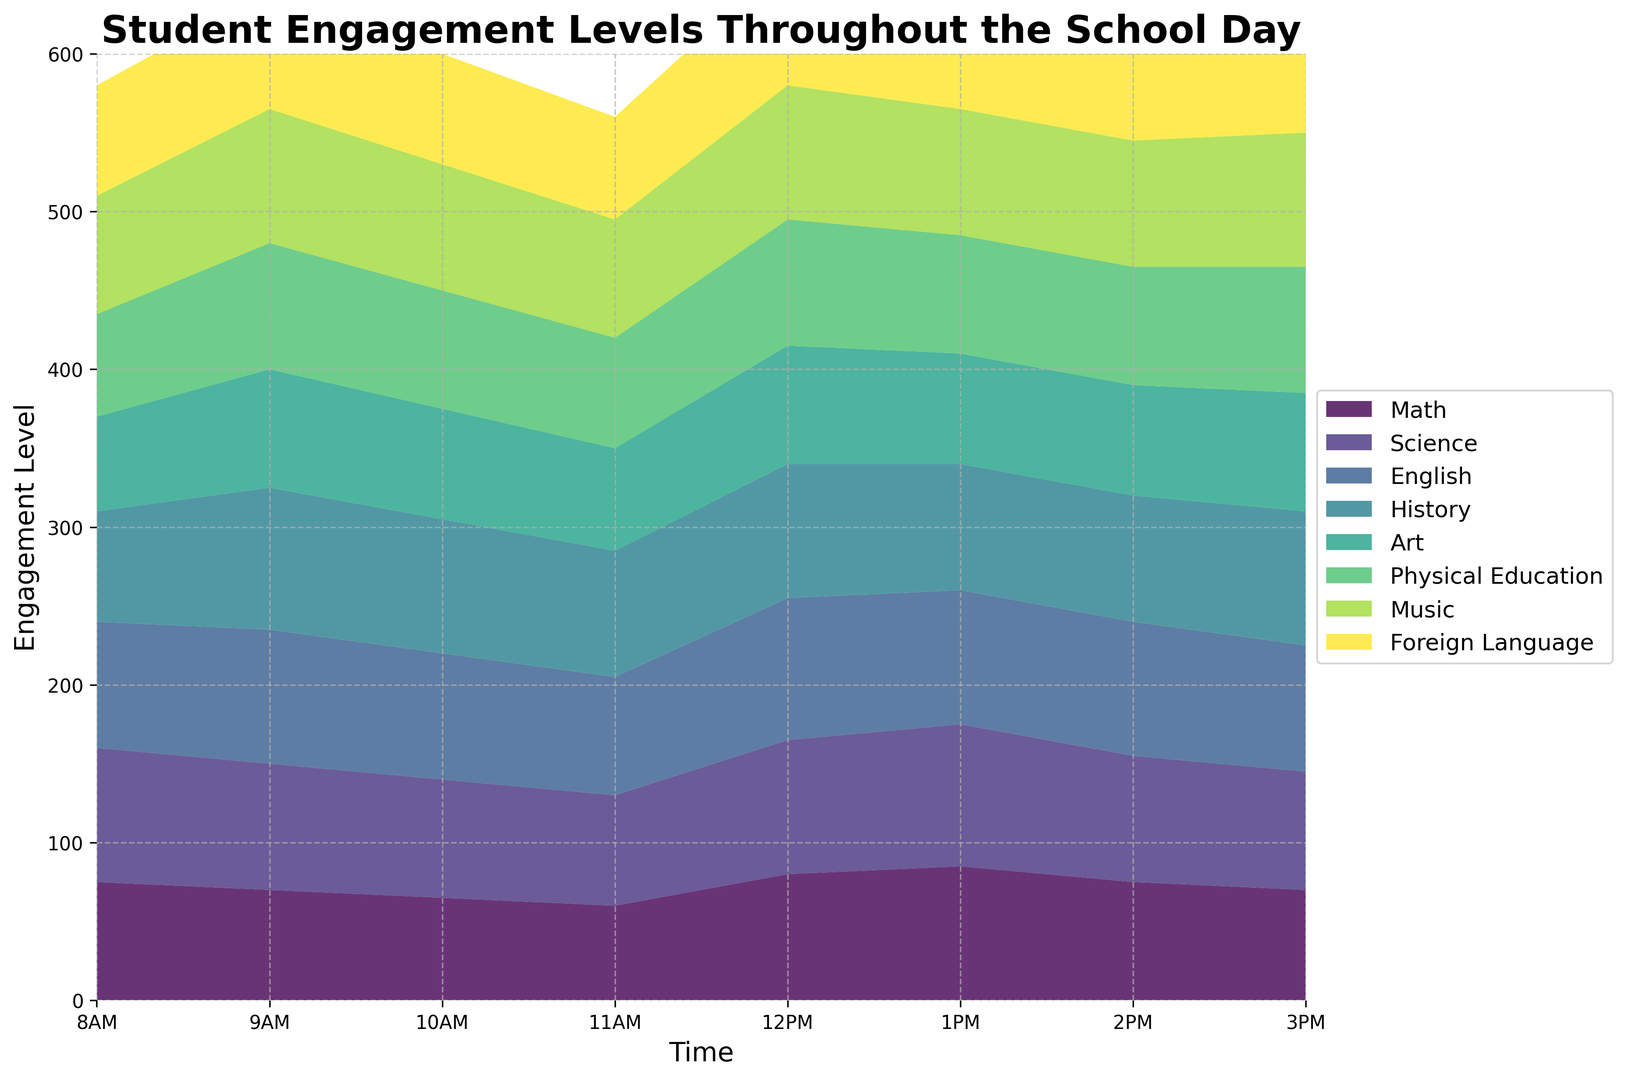What time of the day does Physical Education have the highest engagement level? From the graph, we can see the height of the Physical Education area (represented by its distinct color) is highest at 9AM.
Answer: 9AM Which subject shows a peak in student engagement at 11AM? Observing the heights of all areas at 11AM, the subject with the tallest area is Science.
Answer: Science Compare the engagement levels of Math and English at 10AM. Which one is higher? At 10AM, the height of the Math area is lower than the height of the English area.
Answer: English Summarize the student engagement level trend in Art from 8AM to 3PM. The engagement in Art starts high at 8AM, peaks at 10AM, stays relatively constant until 1PM, and then gradually decreases till 3PM.
Answer: High to moderate decrease What is the combined engagement level of Math and Science at 9AM? The engagement levels at 9AM are 85 (Math) and 80 (Science). Adding these values together gives 85 + 80 = 165.
Answer: 165 Which subject has the lowest engagement at 12PM? At 12PM, the area for Math is lowest compared to other subjects.
Answer: Math By how much does the engagement level of Foreign Language at 11AM exceed that of Math at the same time? At 11AM, the engagement level for Foreign Language is 85 and for Math, it is 70. The difference is 85 - 70 = 15.
Answer: 15 Determine the average engagement level for Music between 8AM and 3PM. The engagement levels for Music at the recorded times are 75, 80, 85, 80, 70, 75, 80, and 75. Summing these gives 620, and the average is 620 / 8 = 77.5.
Answer: 77.5 By what percentage does the engagement level in Science drop from 11AM to 12PM? The engagement level for Science drops from 90 at 11AM to 75 at 12PM. The difference is 90 - 75 = 15. The percentage drop is (15 / 90) * 100 = 16.67%.
Answer: 16.67% Which subjects show a noticeable drop in engagement levels after lunch (12PM)? From 12PM onward, subjects with noticeable drops include Math, History, and English, as their areas show clear decreases.
Answer: Math, History, English 